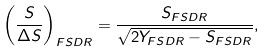Convert formula to latex. <formula><loc_0><loc_0><loc_500><loc_500>\left ( \frac { S } { \Delta S } \right ) _ { F S D R } = \frac { S _ { F S D R } } { \sqrt { 2 Y _ { F S D R } - S _ { F S D R } } } ,</formula> 